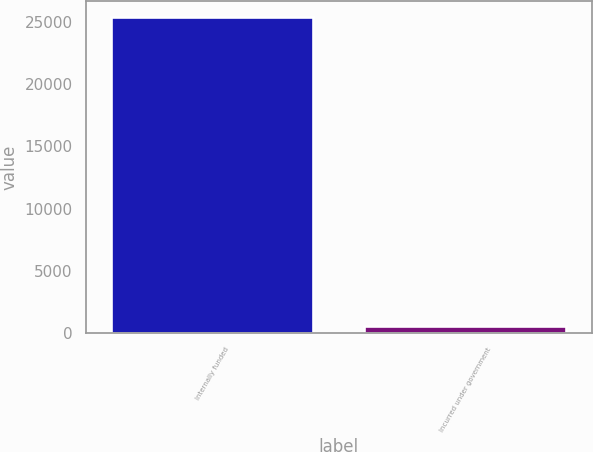Convert chart. <chart><loc_0><loc_0><loc_500><loc_500><bar_chart><fcel>Internally funded<fcel>Incurred under government<nl><fcel>25434<fcel>520<nl></chart> 